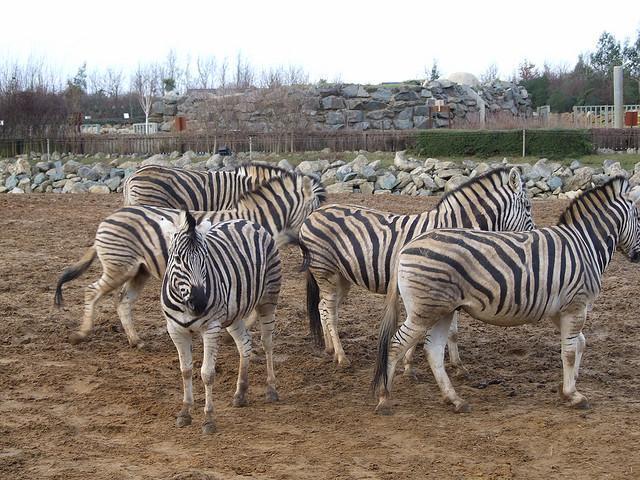How many zebras can you see?
Give a very brief answer. 5. How many different types of animals are in the image?
Give a very brief answer. 1. How many zebras are in the picture?
Give a very brief answer. 5. How many signs are hanging above the toilet that are not written in english?
Give a very brief answer. 0. 